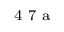Convert formula to latex. <formula><loc_0><loc_0><loc_500><loc_500>^ { 4 } 7 a</formula> 